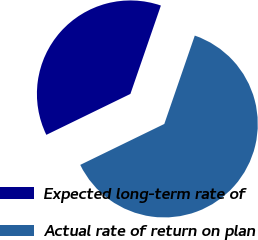<chart> <loc_0><loc_0><loc_500><loc_500><pie_chart><fcel>Expected long-term rate of<fcel>Actual rate of return on plan<nl><fcel>37.5%<fcel>62.5%<nl></chart> 